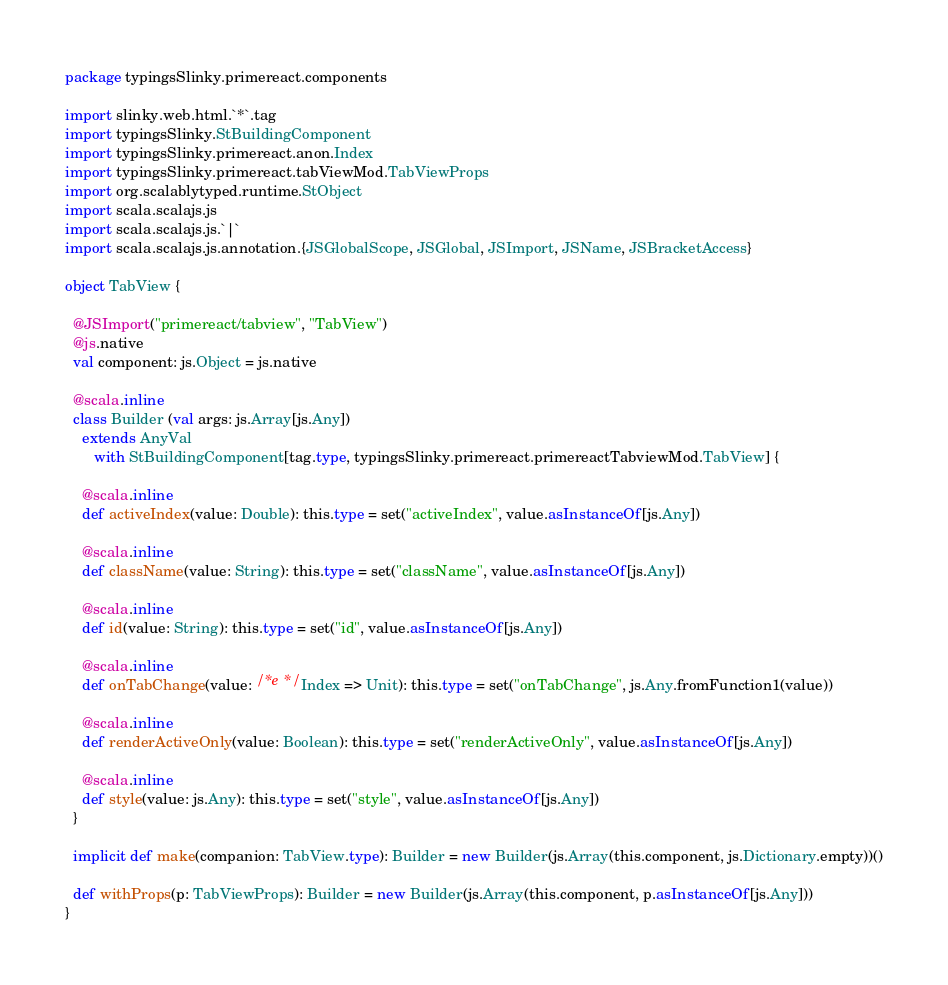<code> <loc_0><loc_0><loc_500><loc_500><_Scala_>package typingsSlinky.primereact.components

import slinky.web.html.`*`.tag
import typingsSlinky.StBuildingComponent
import typingsSlinky.primereact.anon.Index
import typingsSlinky.primereact.tabViewMod.TabViewProps
import org.scalablytyped.runtime.StObject
import scala.scalajs.js
import scala.scalajs.js.`|`
import scala.scalajs.js.annotation.{JSGlobalScope, JSGlobal, JSImport, JSName, JSBracketAccess}

object TabView {
  
  @JSImport("primereact/tabview", "TabView")
  @js.native
  val component: js.Object = js.native
  
  @scala.inline
  class Builder (val args: js.Array[js.Any])
    extends AnyVal
       with StBuildingComponent[tag.type, typingsSlinky.primereact.primereactTabviewMod.TabView] {
    
    @scala.inline
    def activeIndex(value: Double): this.type = set("activeIndex", value.asInstanceOf[js.Any])
    
    @scala.inline
    def className(value: String): this.type = set("className", value.asInstanceOf[js.Any])
    
    @scala.inline
    def id(value: String): this.type = set("id", value.asInstanceOf[js.Any])
    
    @scala.inline
    def onTabChange(value: /* e */ Index => Unit): this.type = set("onTabChange", js.Any.fromFunction1(value))
    
    @scala.inline
    def renderActiveOnly(value: Boolean): this.type = set("renderActiveOnly", value.asInstanceOf[js.Any])
    
    @scala.inline
    def style(value: js.Any): this.type = set("style", value.asInstanceOf[js.Any])
  }
  
  implicit def make(companion: TabView.type): Builder = new Builder(js.Array(this.component, js.Dictionary.empty))()
  
  def withProps(p: TabViewProps): Builder = new Builder(js.Array(this.component, p.asInstanceOf[js.Any]))
}
</code> 